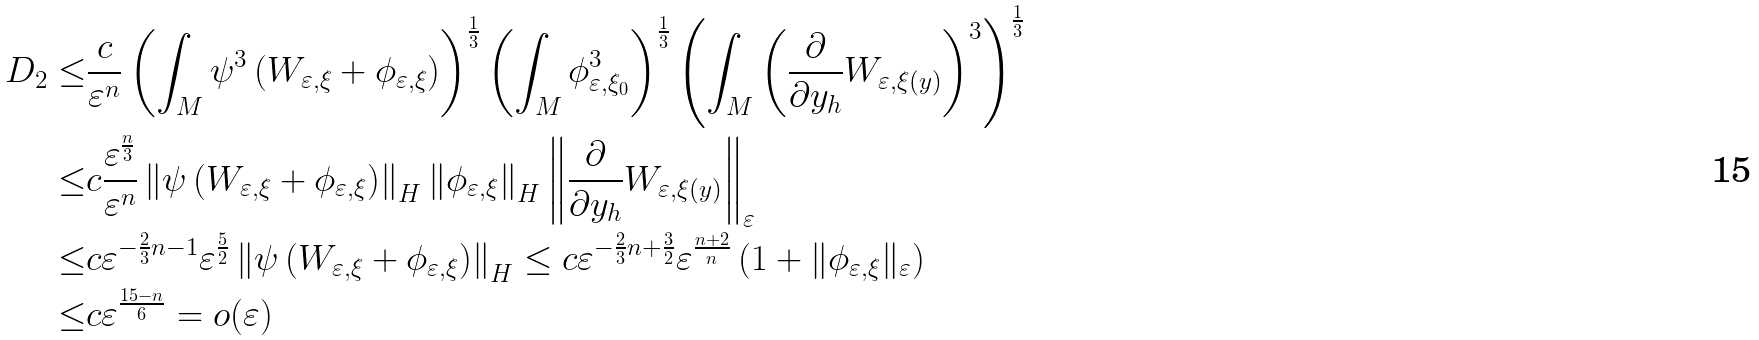<formula> <loc_0><loc_0><loc_500><loc_500>D _ { 2 } \leq & \frac { c } { \varepsilon ^ { n } } \left ( \int _ { M } \psi ^ { 3 } \left ( W _ { \varepsilon , \xi } + \phi _ { \varepsilon , \xi } \right ) \right ) ^ { \frac { 1 } { 3 } } \left ( \int _ { M } \phi _ { \varepsilon , \xi _ { 0 } } ^ { 3 } \right ) ^ { \frac { 1 } { 3 } } \left ( \int _ { M } \left ( \frac { \partial } { \partial y _ { h } } W _ { \varepsilon , \xi ( y ) } \right ) ^ { 3 } \right ) ^ { \frac { 1 } { 3 } } \\ \leq & c \frac { \varepsilon ^ { \frac { n } { 3 } } } { \varepsilon ^ { n } } \left \| \psi \left ( W _ { \varepsilon , \xi } + \phi _ { \varepsilon , \xi } \right ) \right \| _ { H } \left \| \phi _ { \varepsilon , \xi } \right \| _ { H } \left \| \frac { \partial } { \partial y _ { h } } W _ { \varepsilon , \xi ( y ) } \right \| _ { \varepsilon } \\ \leq & c \varepsilon ^ { - \frac { 2 } { 3 } n - 1 } \varepsilon ^ { \frac { 5 } { 2 } } \left \| \psi \left ( W _ { \varepsilon , \xi } + \phi _ { \varepsilon , \xi } \right ) \right \| _ { H } \leq c \varepsilon ^ { - \frac { 2 } { 3 } n + \frac { 3 } { 2 } } \varepsilon ^ { \frac { n + 2 } { n } } \left ( 1 + \| \phi _ { \varepsilon , \xi } \| _ { \varepsilon } \right ) \\ \leq & c \varepsilon ^ { \frac { 1 5 - n } { 6 } } = o ( \varepsilon )</formula> 